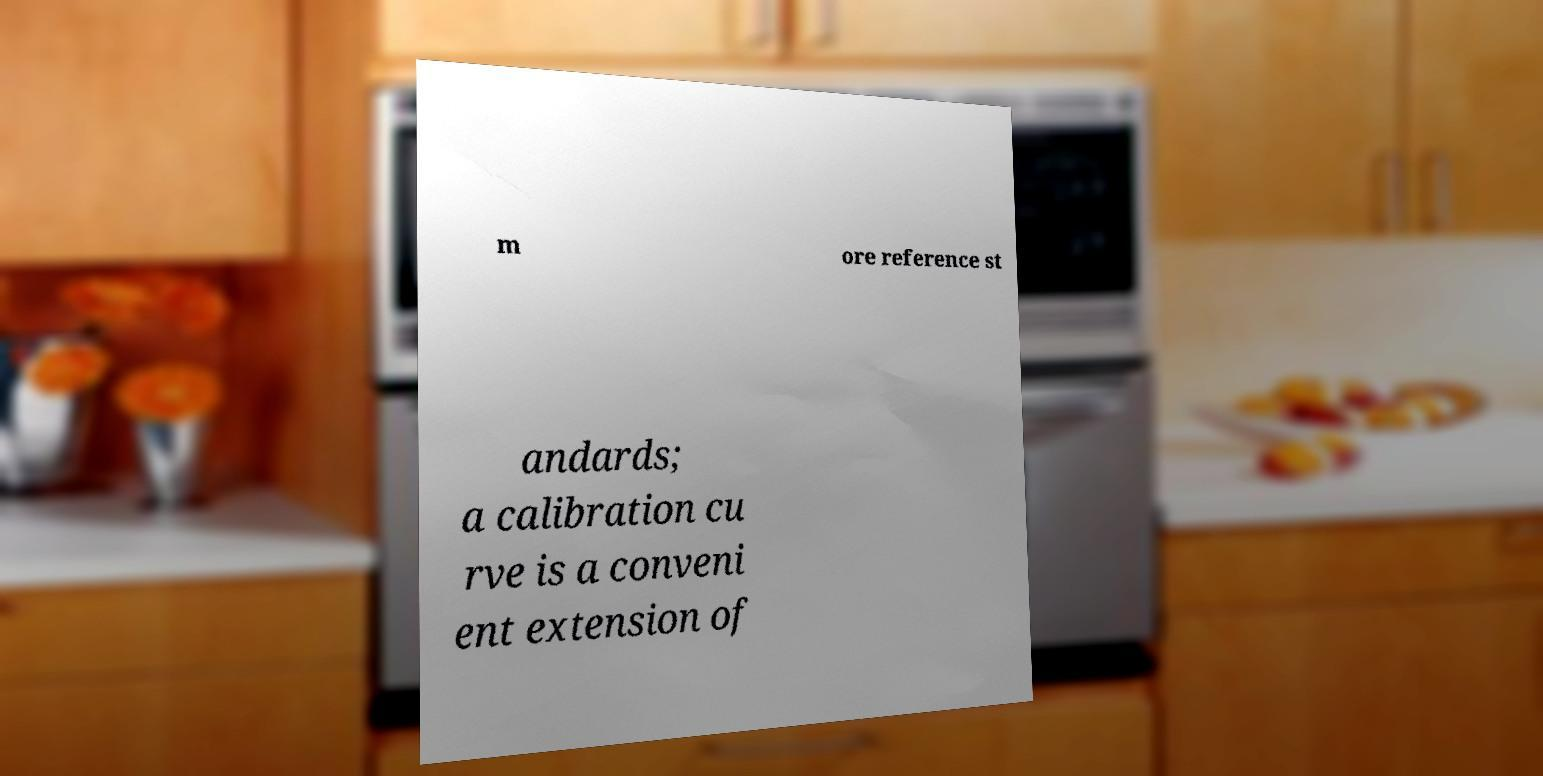Please read and relay the text visible in this image. What does it say? m ore reference st andards; a calibration cu rve is a conveni ent extension of 